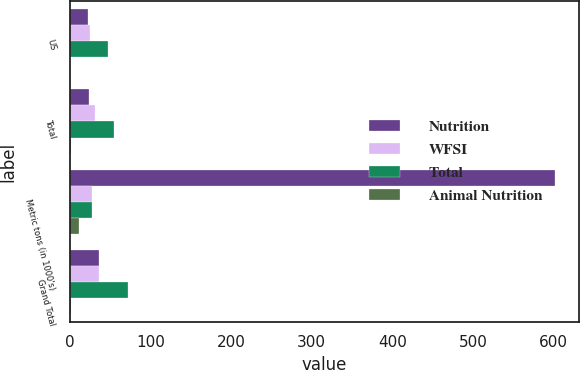Convert chart to OTSL. <chart><loc_0><loc_0><loc_500><loc_500><stacked_bar_chart><ecel><fcel>US<fcel>Total<fcel>Metric tons (in 1000's)<fcel>Grand Total<nl><fcel>Nutrition<fcel>23<fcel>24<fcel>601<fcel>36<nl><fcel>WFSI<fcel>25<fcel>31<fcel>28<fcel>36<nl><fcel>Total<fcel>48<fcel>55<fcel>28<fcel>72<nl><fcel>Animal Nutrition<fcel>1<fcel>2<fcel>11<fcel>2<nl></chart> 